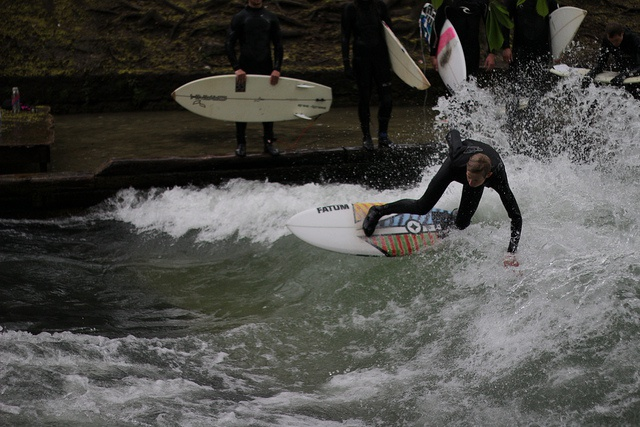Describe the objects in this image and their specific colors. I can see surfboard in black, darkgray, gray, and brown tones, people in black, darkgray, and gray tones, surfboard in black, gray, and darkgray tones, people in black and gray tones, and people in black, maroon, gray, and brown tones in this image. 